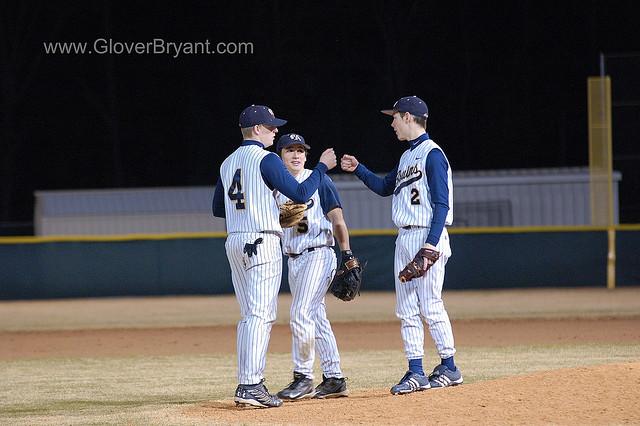What sport are they playing?
Write a very short answer. Baseball. Are there any odd numbered jerseys?
Keep it brief. No. Are they in the middle of playing a game?
Keep it brief. Yes. What is the baseball player doing near the plate?
Keep it brief. Giving fist bump. Is the player wearing shorts?
Be succinct. No. Are these men standing on a plastic tarp?
Concise answer only. No. 